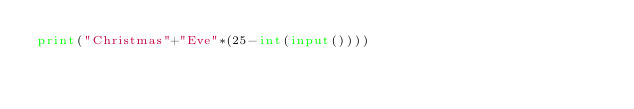<code> <loc_0><loc_0><loc_500><loc_500><_Python_>print("Christmas"+"Eve"*(25-int(input())))</code> 